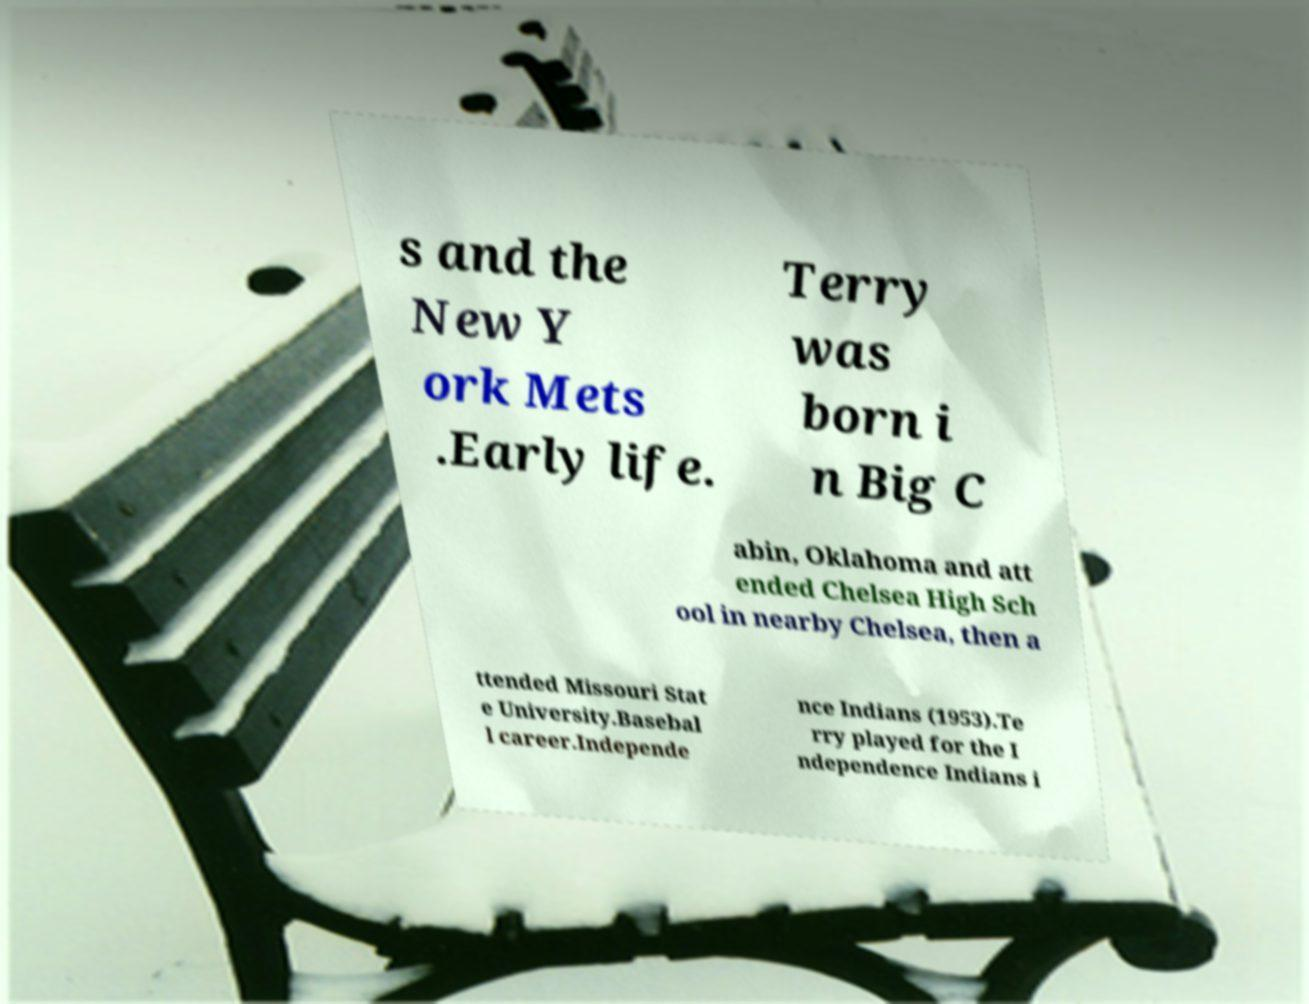Could you assist in decoding the text presented in this image and type it out clearly? s and the New Y ork Mets .Early life. Terry was born i n Big C abin, Oklahoma and att ended Chelsea High Sch ool in nearby Chelsea, then a ttended Missouri Stat e University.Basebal l career.Independe nce Indians (1953).Te rry played for the I ndependence Indians i 